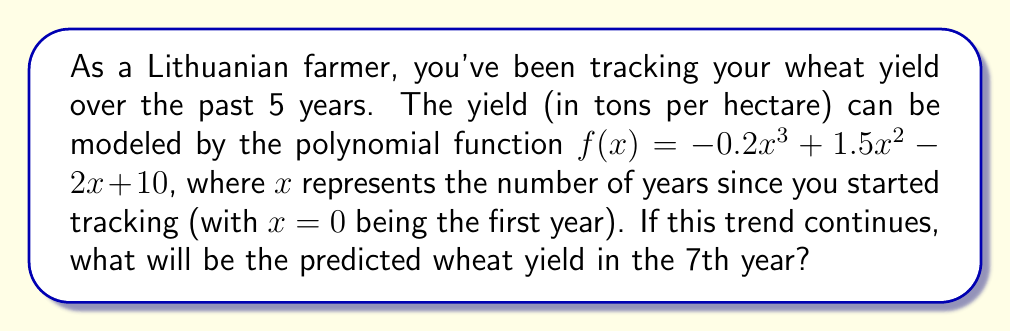Can you answer this question? To solve this problem, we need to follow these steps:

1. Identify the function: $f(x) = -0.2x^3 + 1.5x^2 - 2x + 10$

2. Determine the value of $x$ for the 7th year:
   The 7th year corresponds to $x = 6$ (since $x = 0$ is the first year)

3. Substitute $x = 6$ into the function:
   $f(6) = -0.2(6)^3 + 1.5(6)^2 - 2(6) + 10$

4. Calculate each term:
   $-0.2(6)^3 = -0.2 \cdot 216 = -43.2$
   $1.5(6)^2 = 1.5 \cdot 36 = 54$
   $-2(6) = -12$
   $10$ remains as is

5. Sum up all terms:
   $f(6) = -43.2 + 54 - 12 + 10 = 8.8$

Therefore, the predicted wheat yield in the 7th year will be 8.8 tons per hectare.
Answer: 8.8 tons per hectare 